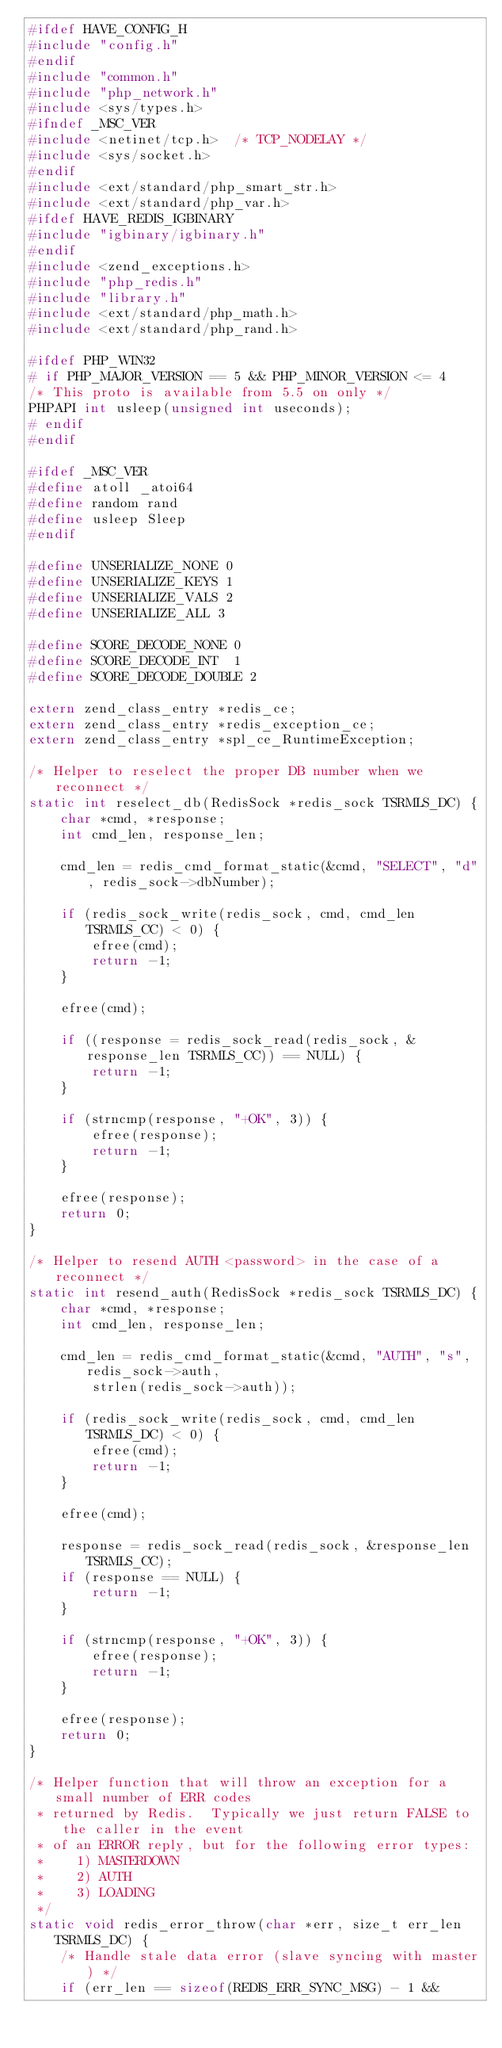<code> <loc_0><loc_0><loc_500><loc_500><_C_>#ifdef HAVE_CONFIG_H
#include "config.h"
#endif
#include "common.h"
#include "php_network.h"
#include <sys/types.h>
#ifndef _MSC_VER
#include <netinet/tcp.h>  /* TCP_NODELAY */
#include <sys/socket.h>
#endif
#include <ext/standard/php_smart_str.h>
#include <ext/standard/php_var.h>
#ifdef HAVE_REDIS_IGBINARY
#include "igbinary/igbinary.h"
#endif
#include <zend_exceptions.h>
#include "php_redis.h"
#include "library.h"
#include <ext/standard/php_math.h>
#include <ext/standard/php_rand.h>

#ifdef PHP_WIN32
# if PHP_MAJOR_VERSION == 5 && PHP_MINOR_VERSION <= 4
/* This proto is available from 5.5 on only */
PHPAPI int usleep(unsigned int useconds);
# endif
#endif

#ifdef _MSC_VER
#define atoll _atoi64
#define random rand
#define usleep Sleep
#endif

#define UNSERIALIZE_NONE 0
#define UNSERIALIZE_KEYS 1
#define UNSERIALIZE_VALS 2
#define UNSERIALIZE_ALL 3

#define SCORE_DECODE_NONE 0
#define SCORE_DECODE_INT  1
#define SCORE_DECODE_DOUBLE 2

extern zend_class_entry *redis_ce;
extern zend_class_entry *redis_exception_ce;
extern zend_class_entry *spl_ce_RuntimeException;

/* Helper to reselect the proper DB number when we reconnect */
static int reselect_db(RedisSock *redis_sock TSRMLS_DC) {
    char *cmd, *response;
    int cmd_len, response_len;

    cmd_len = redis_cmd_format_static(&cmd, "SELECT", "d", redis_sock->dbNumber);

    if (redis_sock_write(redis_sock, cmd, cmd_len TSRMLS_CC) < 0) {
        efree(cmd);
        return -1;
    }

    efree(cmd);

    if ((response = redis_sock_read(redis_sock, &response_len TSRMLS_CC)) == NULL) {
        return -1;
    }

    if (strncmp(response, "+OK", 3)) {
        efree(response);
        return -1;
    }

    efree(response);
    return 0;
}

/* Helper to resend AUTH <password> in the case of a reconnect */
static int resend_auth(RedisSock *redis_sock TSRMLS_DC) {
    char *cmd, *response;
    int cmd_len, response_len;

    cmd_len = redis_cmd_format_static(&cmd, "AUTH", "s", redis_sock->auth,
        strlen(redis_sock->auth));

    if (redis_sock_write(redis_sock, cmd, cmd_len TSRMLS_DC) < 0) {
        efree(cmd);
        return -1;
    }

    efree(cmd);

    response = redis_sock_read(redis_sock, &response_len TSRMLS_CC);
    if (response == NULL) {
        return -1;
    }

    if (strncmp(response, "+OK", 3)) {
        efree(response);
        return -1;
    }

    efree(response);
    return 0;
}

/* Helper function that will throw an exception for a small number of ERR codes
 * returned by Redis.  Typically we just return FALSE to the caller in the event
 * of an ERROR reply, but for the following error types:
 *    1) MASTERDOWN
 *    2) AUTH
 *    3) LOADING
 */
static void redis_error_throw(char *err, size_t err_len TSRMLS_DC) {
    /* Handle stale data error (slave syncing with master) */
    if (err_len == sizeof(REDIS_ERR_SYNC_MSG) - 1 &&</code> 